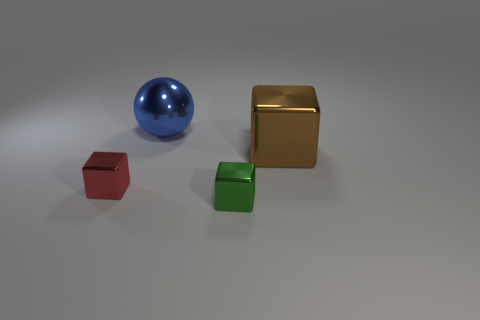Is the number of brown shiny blocks that are right of the large blue sphere less than the number of big shiny blocks?
Offer a terse response. No. What number of other brown metal things have the same size as the brown object?
Your response must be concise. 0. Do the big shiny object that is left of the green thing and the cube left of the tiny green shiny block have the same color?
Give a very brief answer. No. There is a large blue object; how many balls are behind it?
Make the answer very short. 0. Is there a blue object of the same shape as the red metal object?
Your answer should be very brief. No. There is another thing that is the same size as the red thing; what color is it?
Offer a terse response. Green. Are there fewer small shiny cubes in front of the red object than red cubes in front of the green block?
Your response must be concise. No. Does the metal thing right of the green shiny thing have the same size as the blue shiny sphere?
Offer a terse response. Yes. There is a tiny object that is on the left side of the small green metal cube; what is its shape?
Offer a terse response. Cube. Are there more large brown shiny blocks than large objects?
Your response must be concise. No. 